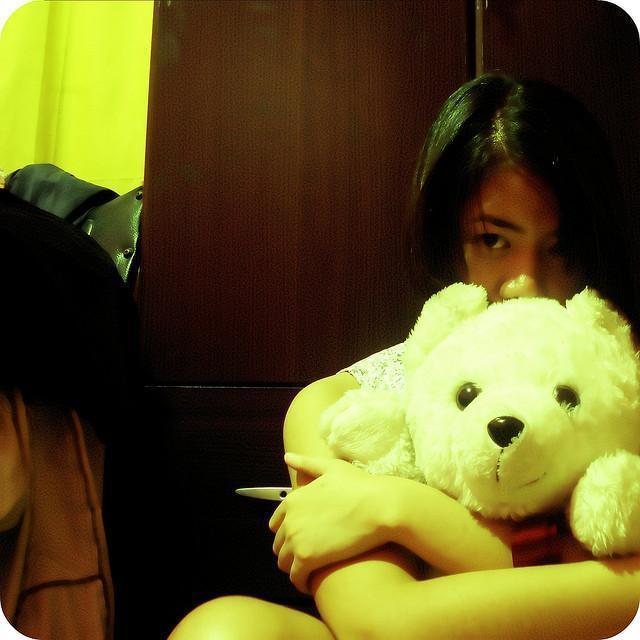Does the caption "The teddy bear is touching the person." correctly depict the image?
Answer yes or no. Yes. Is the statement "The person is behind the teddy bear." accurate regarding the image?
Answer yes or no. Yes. 